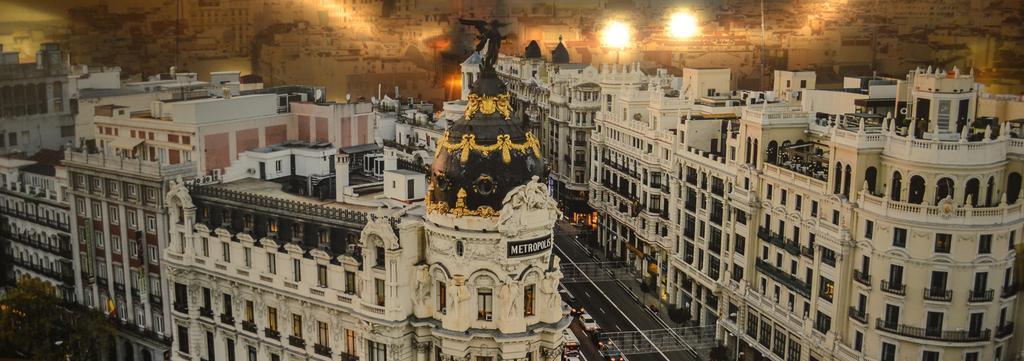Please provide a concise description of this image. This is an outside view. Here I can see many buildings. At the bottom of the image there is a road and I can see few cars on the road. Beside the road there are some trees. 